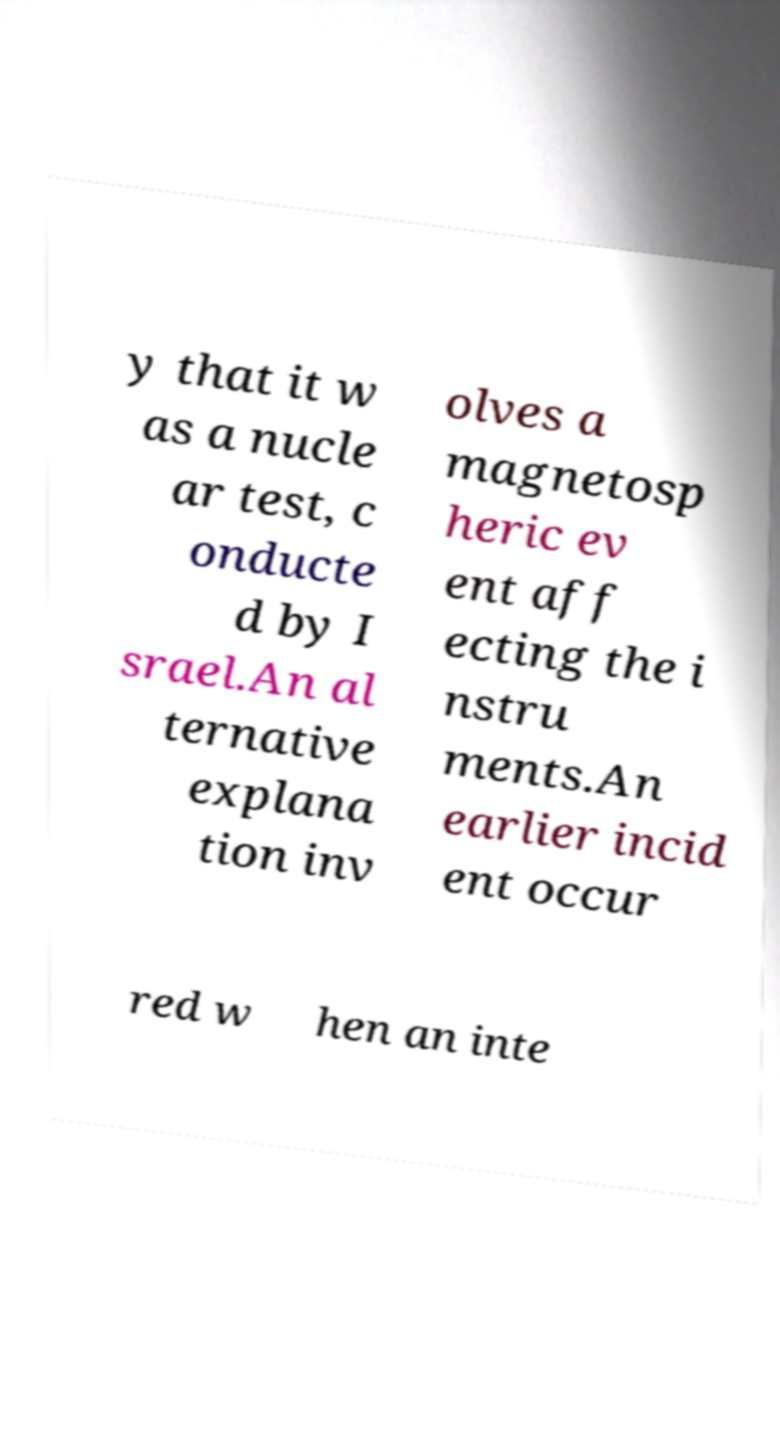Can you accurately transcribe the text from the provided image for me? y that it w as a nucle ar test, c onducte d by I srael.An al ternative explana tion inv olves a magnetosp heric ev ent aff ecting the i nstru ments.An earlier incid ent occur red w hen an inte 